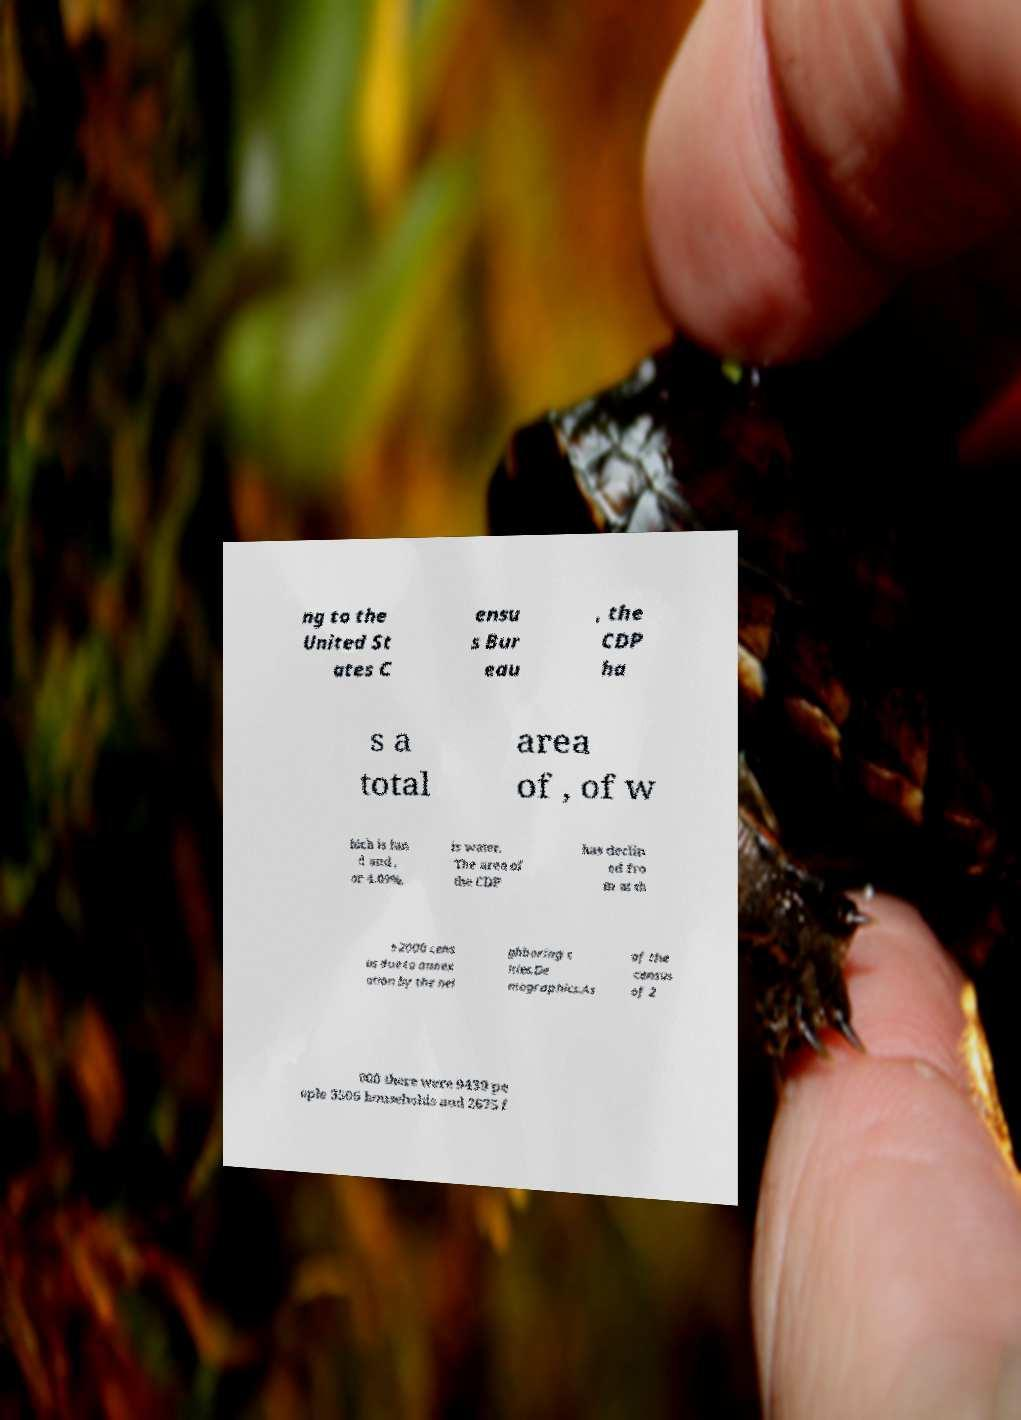Could you extract and type out the text from this image? ng to the United St ates C ensu s Bur eau , the CDP ha s a total area of , of w hich is lan d and , or 4.09%, is water. The area of the CDP has declin ed fro m at th e 2000 cens us due to annex ation by the nei ghboring c ities.De mographics.As of the census of 2 000 there were 9439 pe ople 3506 households and 2675 f 